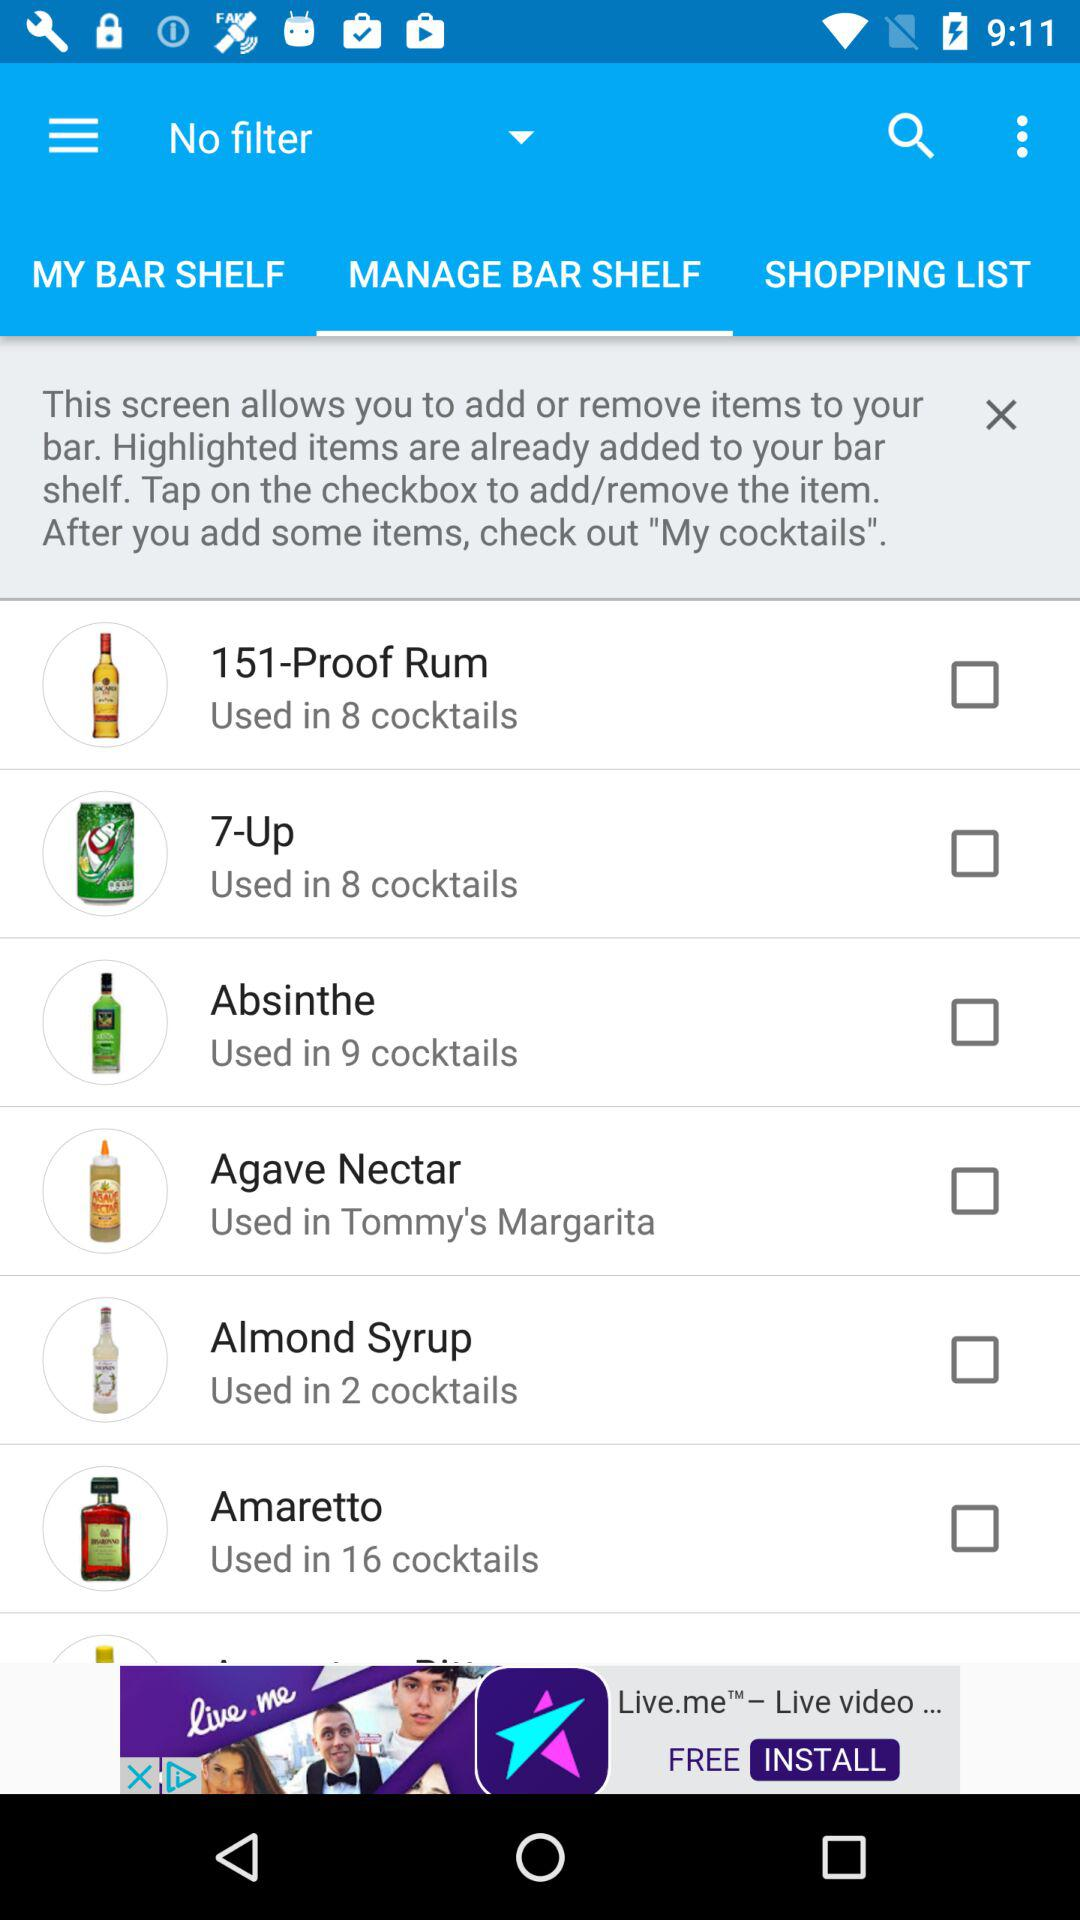In how many cocktails are "7-Up" used? It is used in 8 cocktails. 